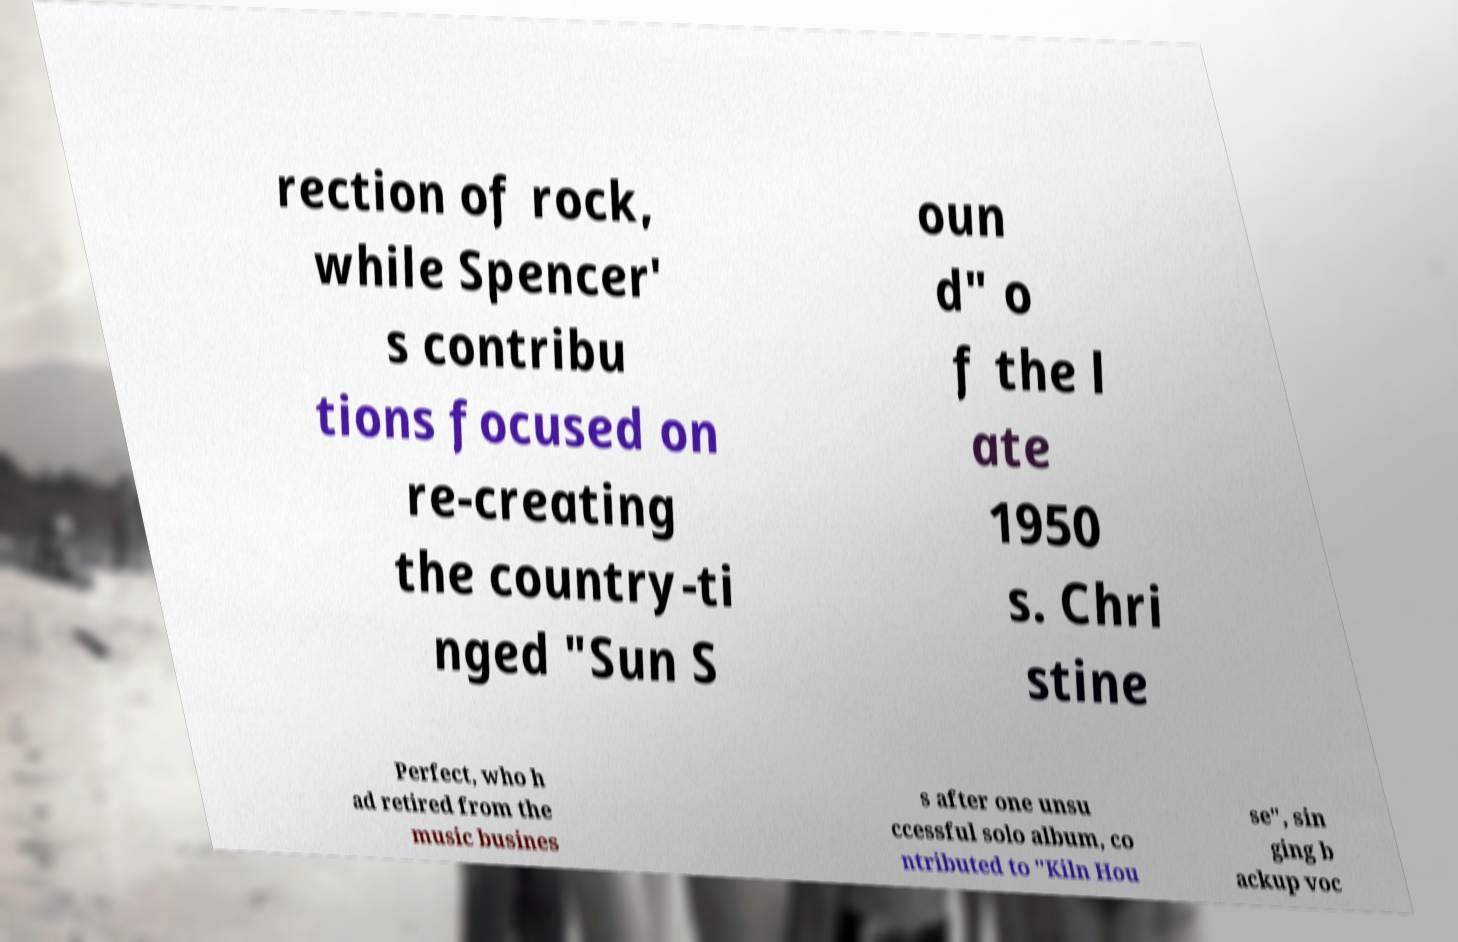Please identify and transcribe the text found in this image. rection of rock, while Spencer' s contribu tions focused on re-creating the country-ti nged "Sun S oun d" o f the l ate 1950 s. Chri stine Perfect, who h ad retired from the music busines s after one unsu ccessful solo album, co ntributed to "Kiln Hou se", sin ging b ackup voc 